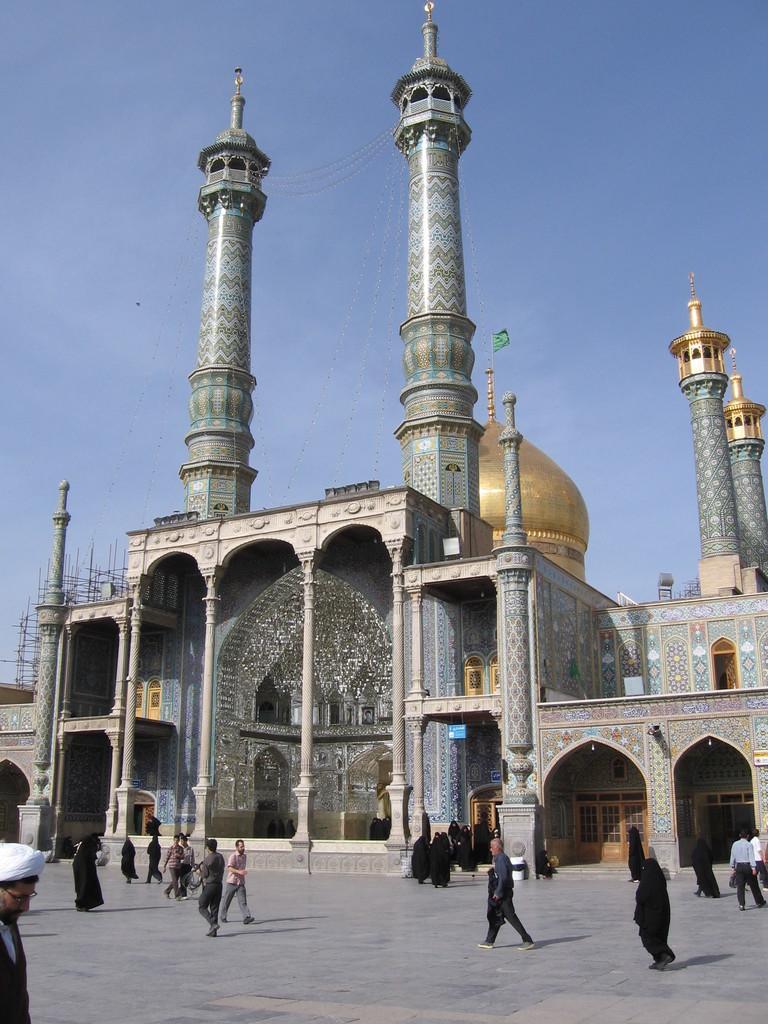Describe this image in one or two sentences. In this image I can see a group of people walking in front of mosque. I can also see a clear blue sky in the background. 